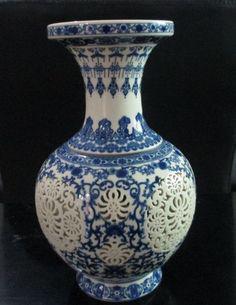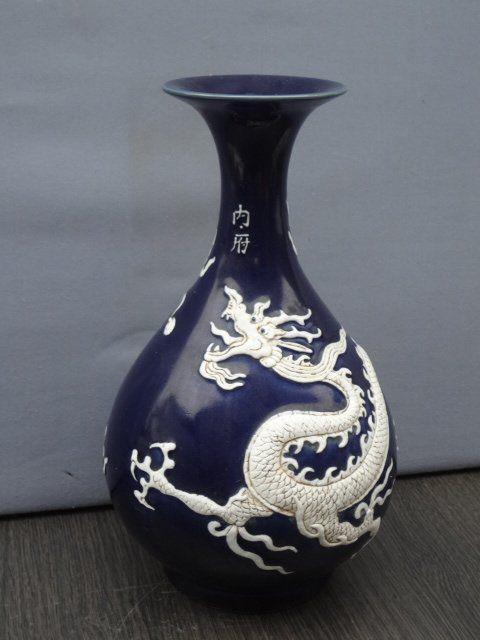The first image is the image on the left, the second image is the image on the right. Given the left and right images, does the statement "One vessel has at least one handle, is widest around the middle, and features a stylized depiction of a hooved animal in black." hold true? Answer yes or no. No. The first image is the image on the left, the second image is the image on the right. Given the left and right images, does the statement "The vase in the image on the left has two handles." hold true? Answer yes or no. No. 